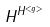<formula> <loc_0><loc_0><loc_500><loc_500>H ^ { H ^ { < g > } }</formula> 